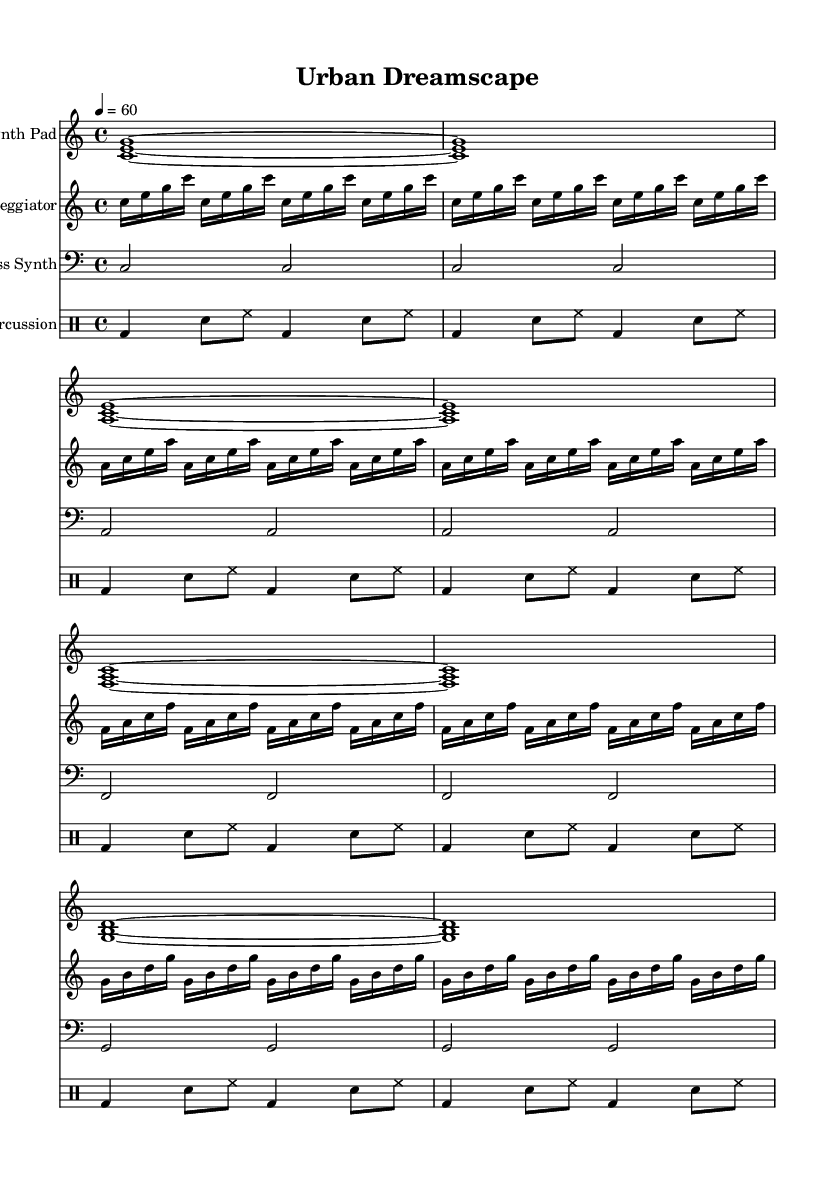What is the key signature of this music? The key signature is indicated at the beginning of the music notation, shown by no sharps or flats, which indicates it is in the C major key.
Answer: C major What is the time signature of this music? The time signature is marked at the beginning of the score as 4/4, meaning there are four beats in each measure and a quarter note gets one beat.
Answer: 4/4 What is the tempo marking of this piece? The tempo marking is indicated by "4 = 60", which means there are 60 beats per minute, and each beat corresponds to a quarter note.
Answer: 60 How many measures are in the Synth Pad part? By visually counting the measures in the Synth Pad staff, we can observe there are a total of 8 measures presented clearly.
Answer: 8 Which instrument is responsible for the rhythmic percussion in this score? The rhythmic percussion is notated in its separate staff under the percussion header, indicating it’s handled by the percussion section, which consists of bass drum, snare, and hi-hat sounds.
Answer: Percussion What type of musical pattern is used in the Arpeggiator part? Upon examining the Arpeggiator part, we see it employs an arpeggiated pattern where notes are played in succession rather than simultaneously, creating an upward flowing texture.
Answer: Arpeggiated What is the lowest pitch used in the sheet music? The lowest pitch can be identified in the Bass Synth which is written on the bass clef, and the lowest note displayed is C, which is in the second octave.
Answer: C 